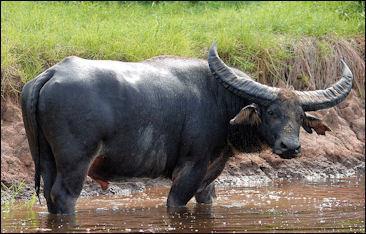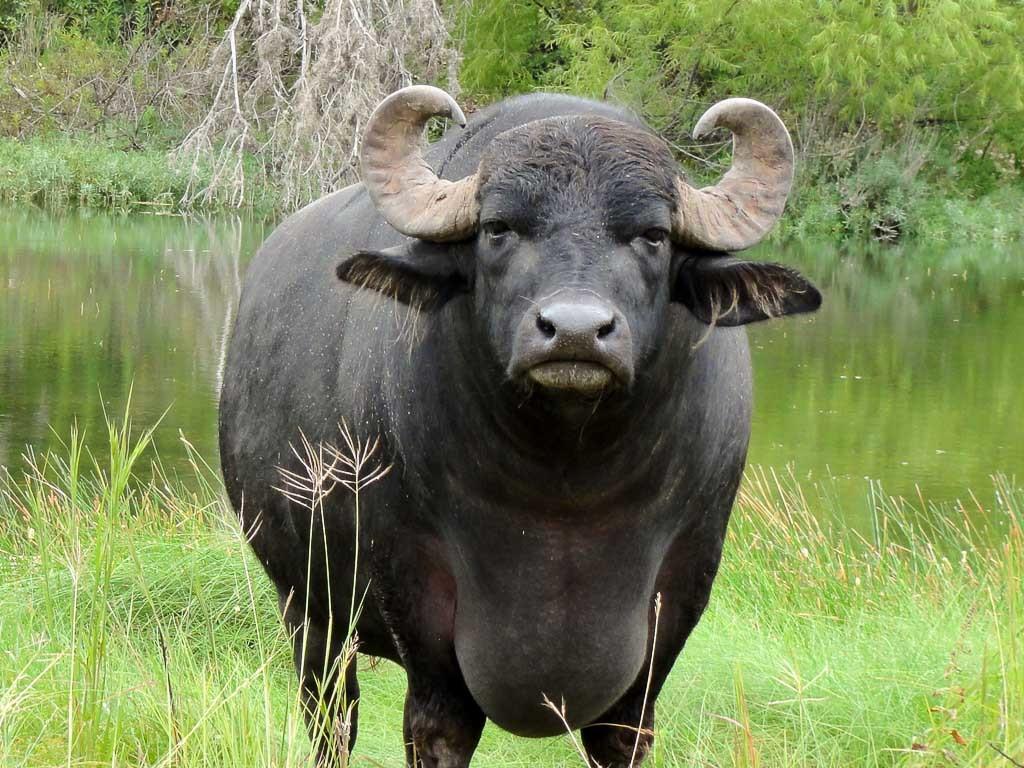The first image is the image on the left, the second image is the image on the right. Analyze the images presented: Is the assertion "No other animal is pictured except for two bulls." valid? Answer yes or no. Yes. 